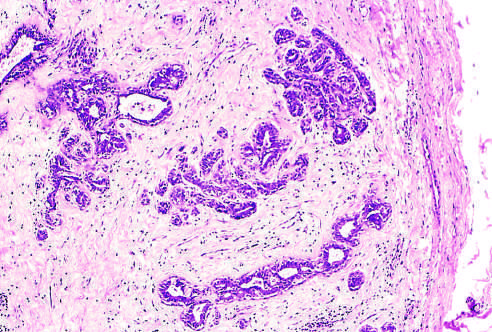does the fibrous capsule delimit the tumor from the surrounding tissue?
Answer the question using a single word or phrase. Yes 